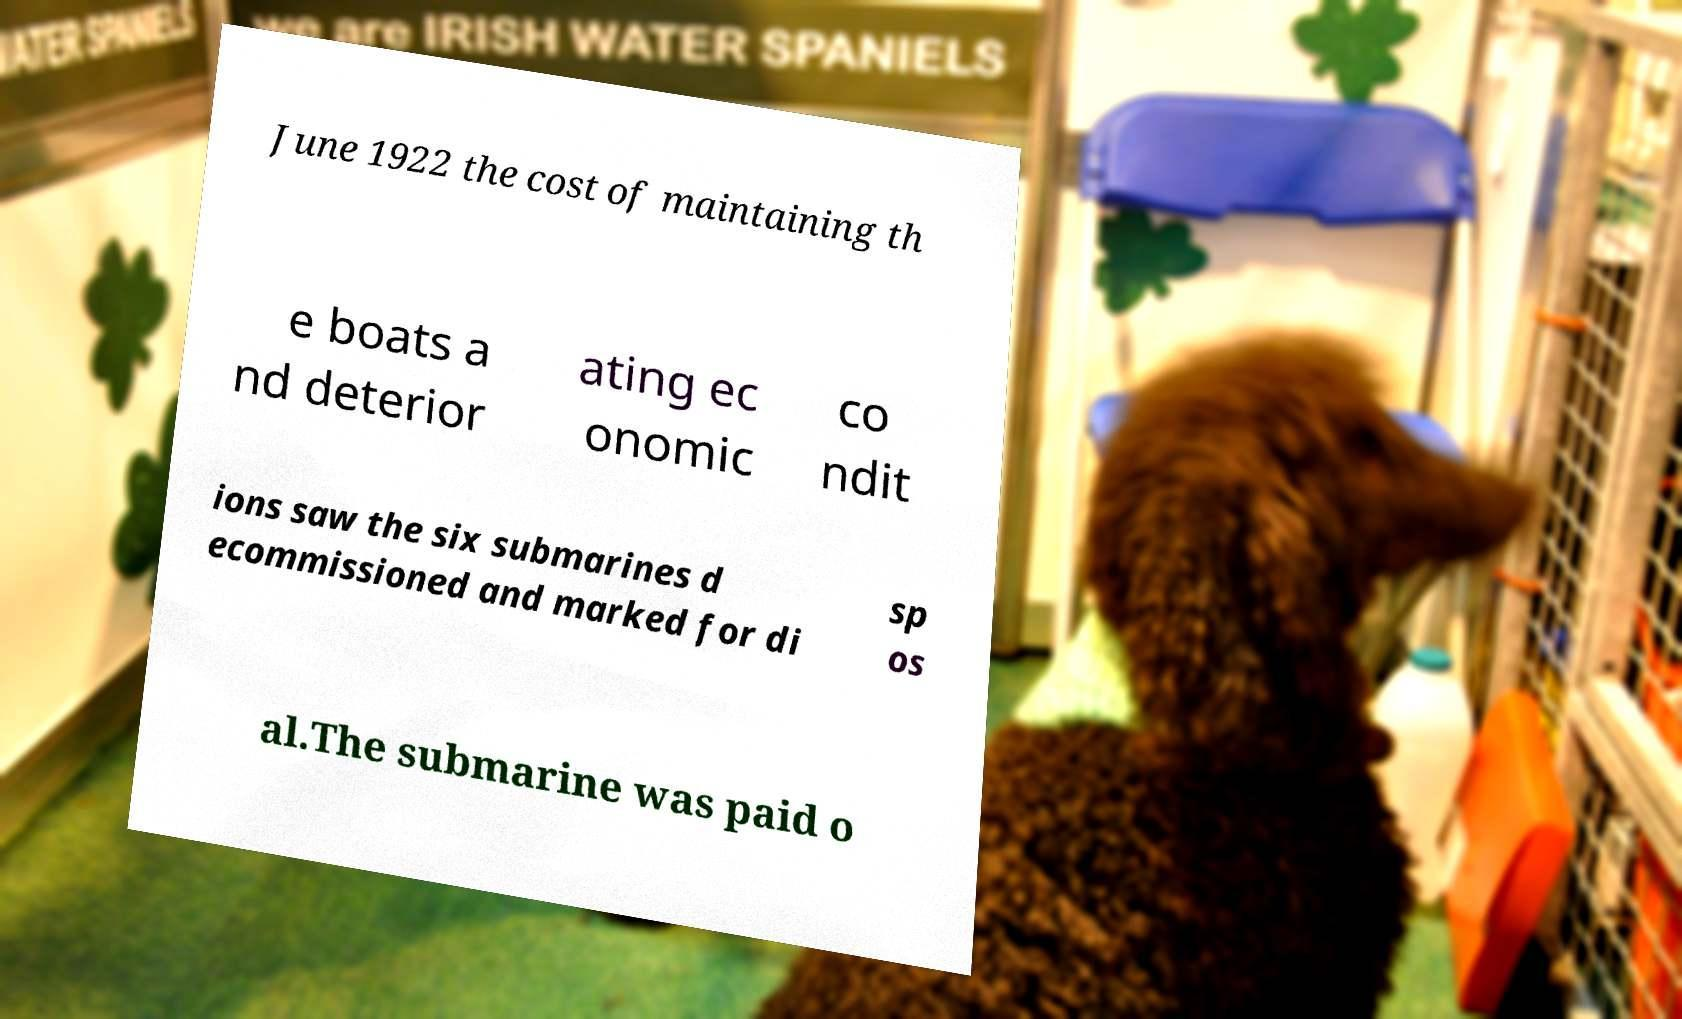Please read and relay the text visible in this image. What does it say? June 1922 the cost of maintaining th e boats a nd deterior ating ec onomic co ndit ions saw the six submarines d ecommissioned and marked for di sp os al.The submarine was paid o 